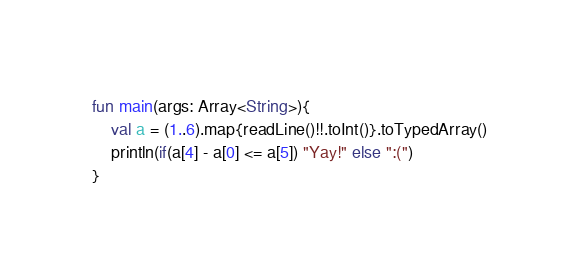<code> <loc_0><loc_0><loc_500><loc_500><_Kotlin_>fun main(args: Array<String>){
    val a = (1..6).map{readLine()!!.toInt()}.toTypedArray()
    println(if(a[4] - a[0] <= a[5]) "Yay!" else ":(")
}</code> 